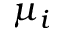Convert formula to latex. <formula><loc_0><loc_0><loc_500><loc_500>\mu _ { i }</formula> 